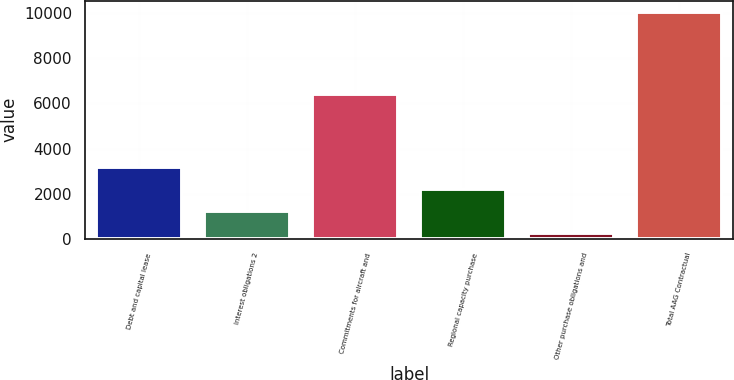Convert chart to OTSL. <chart><loc_0><loc_0><loc_500><loc_500><bar_chart><fcel>Debt and capital lease<fcel>Interest obligations 2<fcel>Commitments for aircraft and<fcel>Regional capacity purchase<fcel>Other purchase obligations and<fcel>Total AAG Contractual<nl><fcel>3202<fcel>1250<fcel>6387<fcel>2226<fcel>274<fcel>10034<nl></chart> 